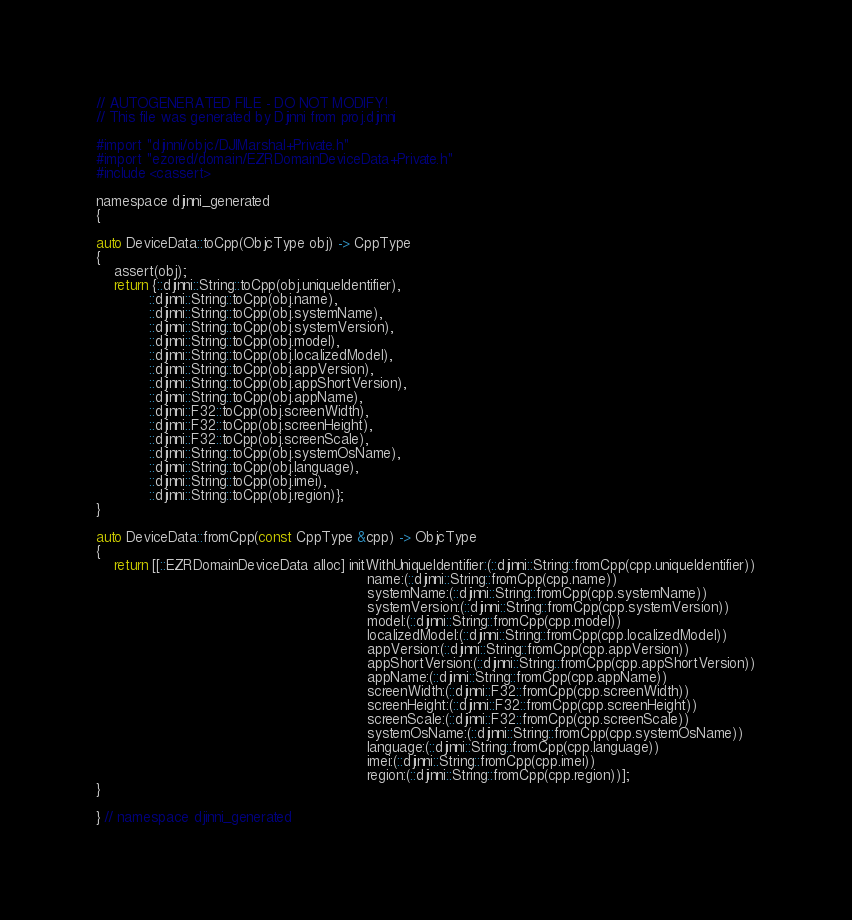<code> <loc_0><loc_0><loc_500><loc_500><_ObjectiveC_>// AUTOGENERATED FILE - DO NOT MODIFY!
// This file was generated by Djinni from proj.djinni

#import "djinni/objc/DJIMarshal+Private.h"
#import "ezored/domain/EZRDomainDeviceData+Private.h"
#include <cassert>

namespace djinni_generated
{

auto DeviceData::toCpp(ObjcType obj) -> CppType
{
    assert(obj);
    return {::djinni::String::toCpp(obj.uniqueIdentifier),
            ::djinni::String::toCpp(obj.name),
            ::djinni::String::toCpp(obj.systemName),
            ::djinni::String::toCpp(obj.systemVersion),
            ::djinni::String::toCpp(obj.model),
            ::djinni::String::toCpp(obj.localizedModel),
            ::djinni::String::toCpp(obj.appVersion),
            ::djinni::String::toCpp(obj.appShortVersion),
            ::djinni::String::toCpp(obj.appName),
            ::djinni::F32::toCpp(obj.screenWidth),
            ::djinni::F32::toCpp(obj.screenHeight),
            ::djinni::F32::toCpp(obj.screenScale),
            ::djinni::String::toCpp(obj.systemOsName),
            ::djinni::String::toCpp(obj.language),
            ::djinni::String::toCpp(obj.imei),
            ::djinni::String::toCpp(obj.region)};
}

auto DeviceData::fromCpp(const CppType &cpp) -> ObjcType
{
    return [[::EZRDomainDeviceData alloc] initWithUniqueIdentifier:(::djinni::String::fromCpp(cpp.uniqueIdentifier))
                                                              name:(::djinni::String::fromCpp(cpp.name))
                                                              systemName:(::djinni::String::fromCpp(cpp.systemName))
                                                              systemVersion:(::djinni::String::fromCpp(cpp.systemVersion))
                                                              model:(::djinni::String::fromCpp(cpp.model))
                                                              localizedModel:(::djinni::String::fromCpp(cpp.localizedModel))
                                                              appVersion:(::djinni::String::fromCpp(cpp.appVersion))
                                                              appShortVersion:(::djinni::String::fromCpp(cpp.appShortVersion))
                                                              appName:(::djinni::String::fromCpp(cpp.appName))
                                                              screenWidth:(::djinni::F32::fromCpp(cpp.screenWidth))
                                                              screenHeight:(::djinni::F32::fromCpp(cpp.screenHeight))
                                                              screenScale:(::djinni::F32::fromCpp(cpp.screenScale))
                                                              systemOsName:(::djinni::String::fromCpp(cpp.systemOsName))
                                                              language:(::djinni::String::fromCpp(cpp.language))
                                                              imei:(::djinni::String::fromCpp(cpp.imei))
                                                              region:(::djinni::String::fromCpp(cpp.region))];
}

} // namespace djinni_generated
</code> 